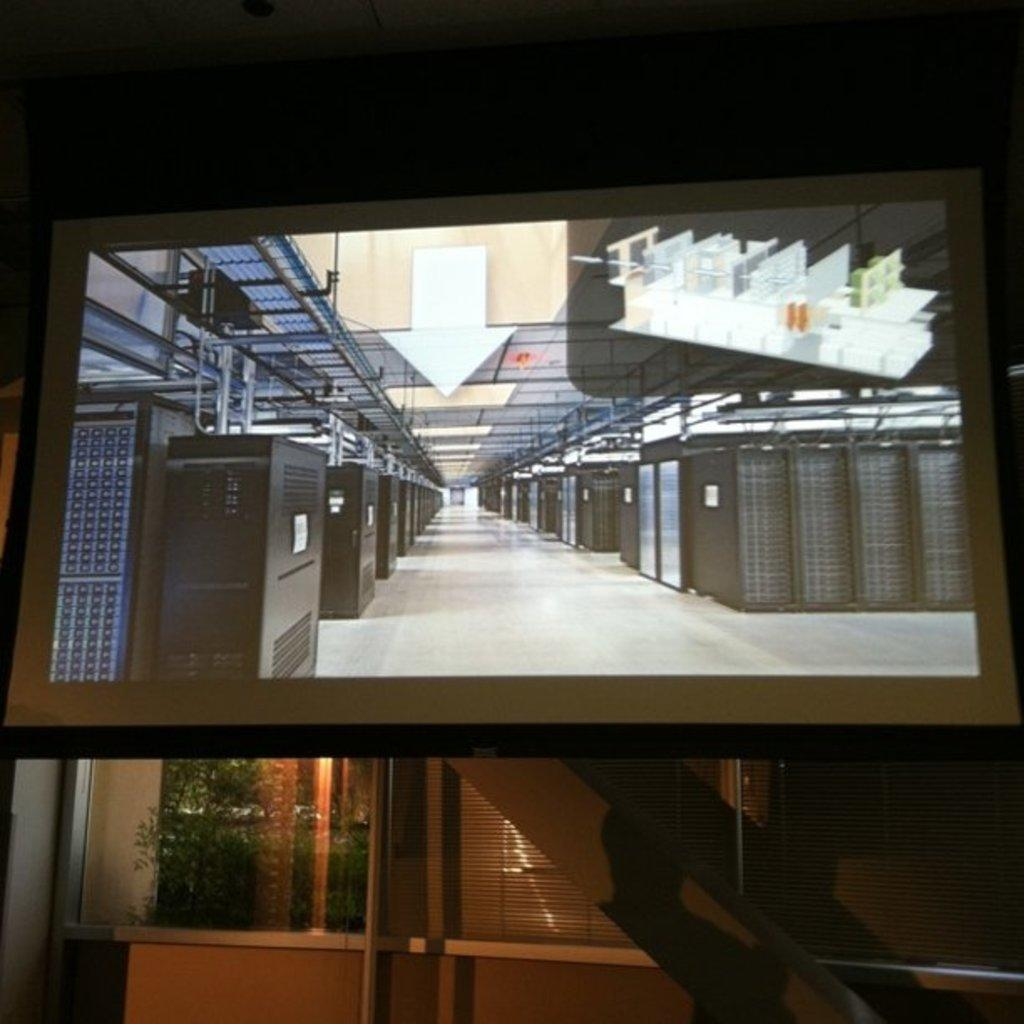What is being displayed on the screen in the image? There is a screen displaying objects in the image. Where are the objects located in relation to the screen? The objects are on the floor. What can be seen in the background of the image? There is a wall in the background of the image. What feature is present on the wall? The wall has a window. What is visible through the window? Plants are visible through the window. Can you tell me what the friend is saying about the objects on the floor? There is no friend present in the image, nor is there any conversation taking place. 